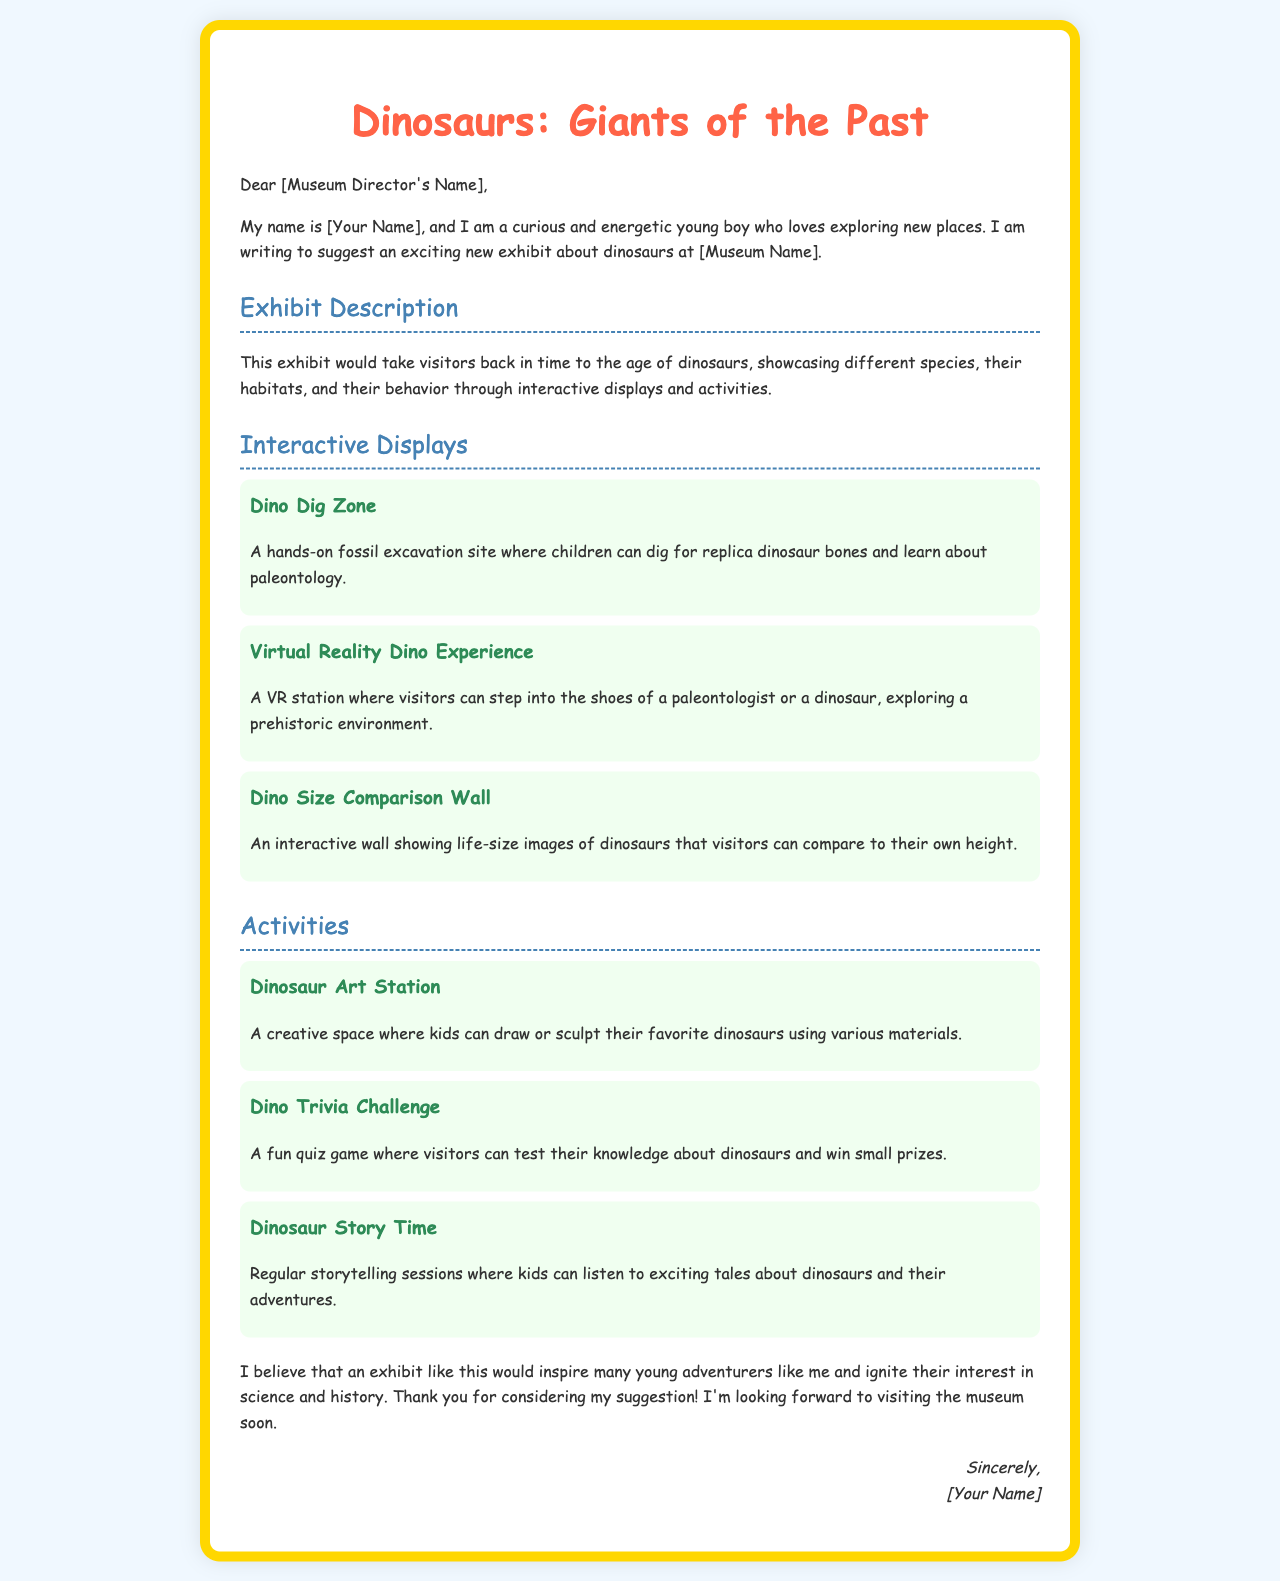What is the title of the letter? The title is the main heading that indicates the topic of the letter.
Answer: Dinosaurs: Giants of the Past Who is the letter addressed to? The letter is directed to a specific person, in this case, the museum director.
Answer: [Museum Director's Name] What interactive display allows children to dig for dinosaur bones? This is a specific activity mentioned in the interactive displays.
Answer: Dino Dig Zone How many activities are listed in the letter? The total activities can be counted from the section heading.
Answer: Three What key idea is emphasized in the letter for the exhibit? The main theme or purpose of the exhibit is highlighted in the document.
Answer: Inspire young adventurers What creative activity is suggested in the letter? This refers to a specific activity promoting creativity among visitors.
Answer: Dinosaur Art Station What does the letter suggest hosts storytelling sessions? This indicates a particular type of activity aimed at entertainment and education.
Answer: Dinosaur Story Time What medium is suggested for the "Dino Trivia Challenge"? This relates to the format through which the trivia is conducted.
Answer: Quiz game What is the full name of the author? This refers to the name at the end of the letter.
Answer: [Your Name] 